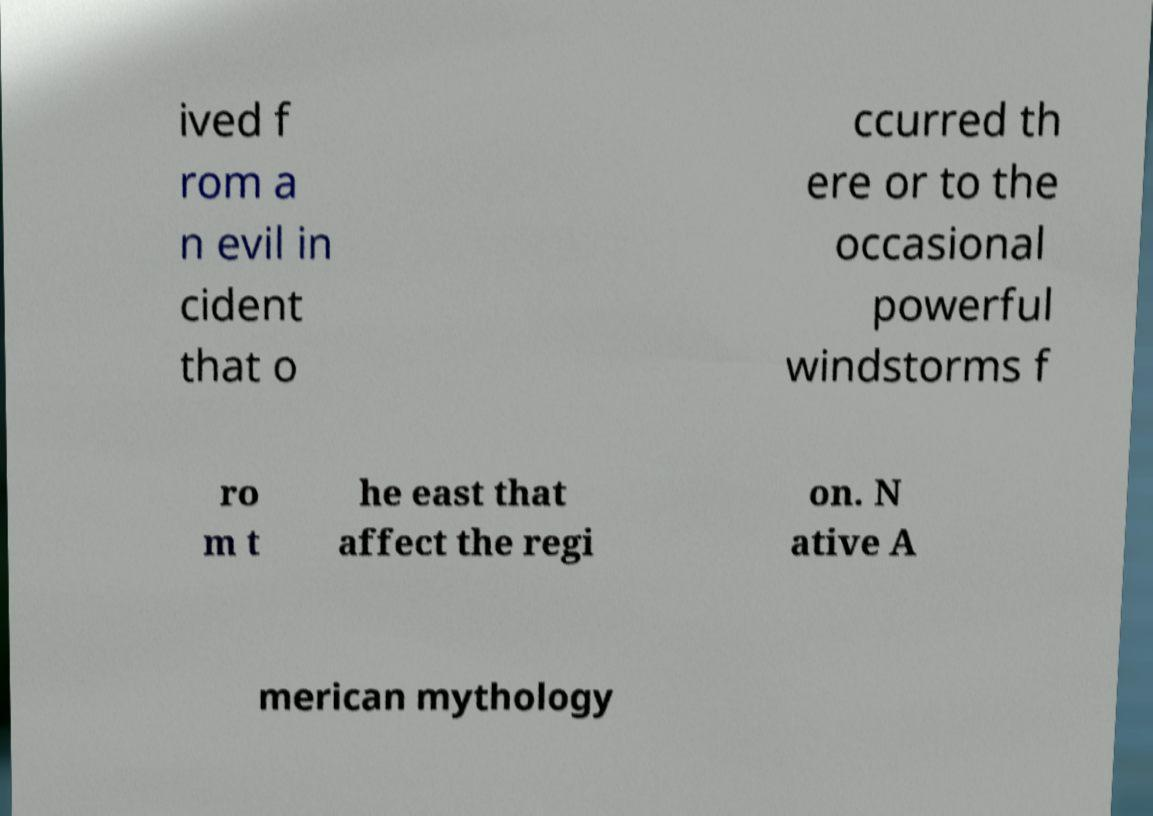Could you extract and type out the text from this image? ived f rom a n evil in cident that o ccurred th ere or to the occasional powerful windstorms f ro m t he east that affect the regi on. N ative A merican mythology 